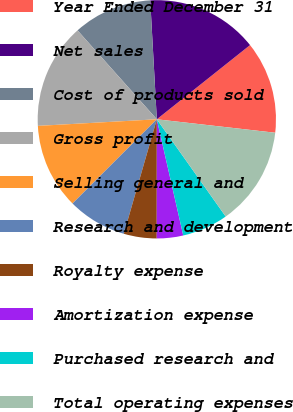Convert chart. <chart><loc_0><loc_0><loc_500><loc_500><pie_chart><fcel>Year Ended December 31<fcel>Net sales<fcel>Cost of products sold<fcel>Gross profit<fcel>Selling general and<fcel>Research and development<fcel>Royalty expense<fcel>Amortization expense<fcel>Purchased research and<fcel>Total operating expenses<nl><fcel>12.5%<fcel>15.18%<fcel>10.71%<fcel>14.29%<fcel>11.61%<fcel>8.04%<fcel>4.46%<fcel>3.57%<fcel>6.25%<fcel>13.39%<nl></chart> 